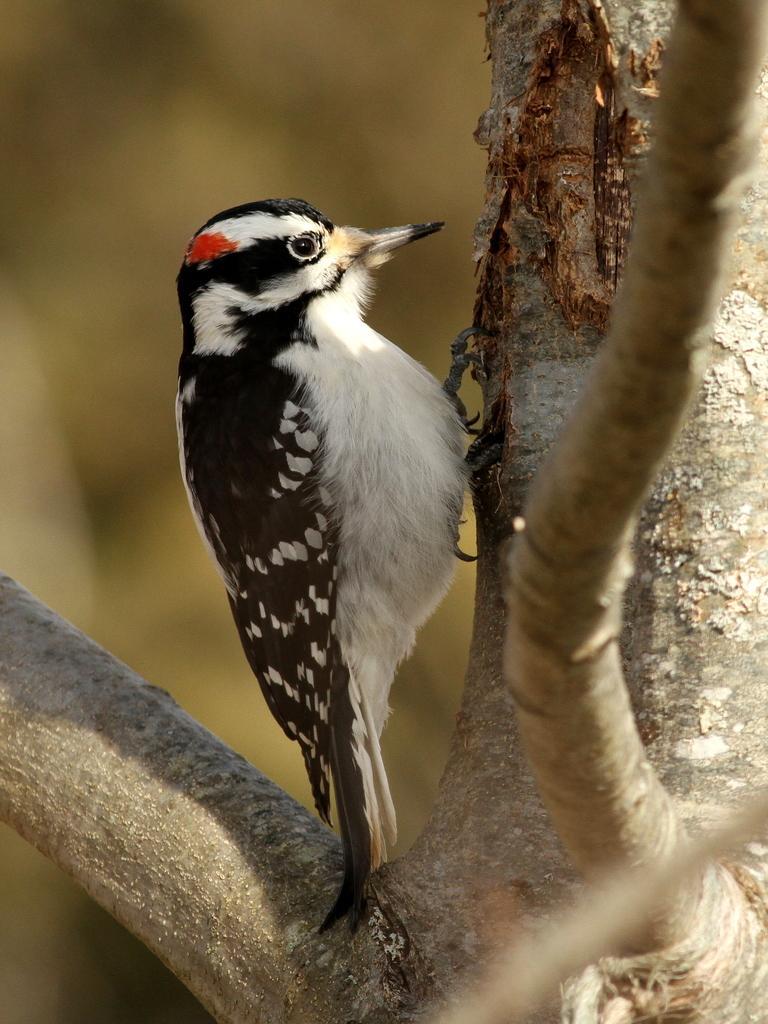Could you give a brief overview of what you see in this image? In this picture I can see tree branches in front and I see a bird on a tree branch and I see that the bird is of white, black and red in color and I see that it is blurred in the background. 